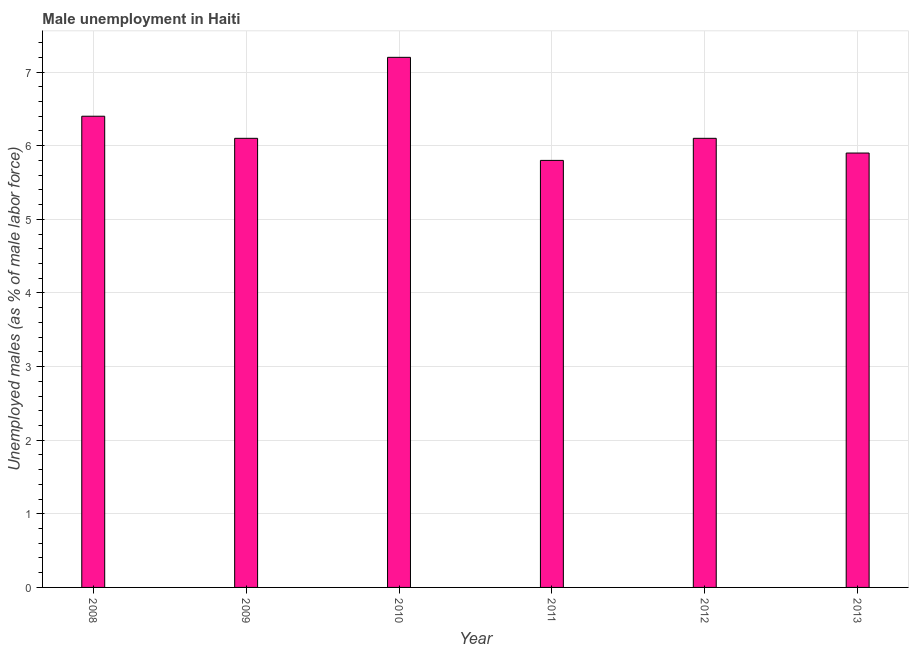What is the title of the graph?
Your answer should be very brief. Male unemployment in Haiti. What is the label or title of the Y-axis?
Your response must be concise. Unemployed males (as % of male labor force). What is the unemployed males population in 2011?
Give a very brief answer. 5.8. Across all years, what is the maximum unemployed males population?
Keep it short and to the point. 7.2. Across all years, what is the minimum unemployed males population?
Ensure brevity in your answer.  5.8. In which year was the unemployed males population minimum?
Provide a succinct answer. 2011. What is the sum of the unemployed males population?
Provide a succinct answer. 37.5. What is the average unemployed males population per year?
Make the answer very short. 6.25. What is the median unemployed males population?
Your response must be concise. 6.1. Do a majority of the years between 2009 and 2012 (inclusive) have unemployed males population greater than 0.2 %?
Your response must be concise. Yes. What is the ratio of the unemployed males population in 2009 to that in 2011?
Your response must be concise. 1.05. What is the difference between the highest and the second highest unemployed males population?
Your answer should be compact. 0.8. How many bars are there?
Give a very brief answer. 6. Are all the bars in the graph horizontal?
Provide a succinct answer. No. What is the Unemployed males (as % of male labor force) of 2008?
Keep it short and to the point. 6.4. What is the Unemployed males (as % of male labor force) in 2009?
Your response must be concise. 6.1. What is the Unemployed males (as % of male labor force) in 2010?
Your answer should be very brief. 7.2. What is the Unemployed males (as % of male labor force) in 2011?
Your response must be concise. 5.8. What is the Unemployed males (as % of male labor force) in 2012?
Provide a short and direct response. 6.1. What is the Unemployed males (as % of male labor force) in 2013?
Your response must be concise. 5.9. What is the difference between the Unemployed males (as % of male labor force) in 2008 and 2009?
Your answer should be very brief. 0.3. What is the difference between the Unemployed males (as % of male labor force) in 2008 and 2013?
Ensure brevity in your answer.  0.5. What is the difference between the Unemployed males (as % of male labor force) in 2009 and 2010?
Your answer should be very brief. -1.1. What is the difference between the Unemployed males (as % of male labor force) in 2009 and 2011?
Your answer should be very brief. 0.3. What is the difference between the Unemployed males (as % of male labor force) in 2009 and 2012?
Offer a terse response. 0. What is the difference between the Unemployed males (as % of male labor force) in 2010 and 2011?
Your response must be concise. 1.4. What is the ratio of the Unemployed males (as % of male labor force) in 2008 to that in 2009?
Provide a short and direct response. 1.05. What is the ratio of the Unemployed males (as % of male labor force) in 2008 to that in 2010?
Your response must be concise. 0.89. What is the ratio of the Unemployed males (as % of male labor force) in 2008 to that in 2011?
Your response must be concise. 1.1. What is the ratio of the Unemployed males (as % of male labor force) in 2008 to that in 2012?
Your answer should be compact. 1.05. What is the ratio of the Unemployed males (as % of male labor force) in 2008 to that in 2013?
Your response must be concise. 1.08. What is the ratio of the Unemployed males (as % of male labor force) in 2009 to that in 2010?
Provide a succinct answer. 0.85. What is the ratio of the Unemployed males (as % of male labor force) in 2009 to that in 2011?
Provide a short and direct response. 1.05. What is the ratio of the Unemployed males (as % of male labor force) in 2009 to that in 2012?
Give a very brief answer. 1. What is the ratio of the Unemployed males (as % of male labor force) in 2009 to that in 2013?
Give a very brief answer. 1.03. What is the ratio of the Unemployed males (as % of male labor force) in 2010 to that in 2011?
Keep it short and to the point. 1.24. What is the ratio of the Unemployed males (as % of male labor force) in 2010 to that in 2012?
Your answer should be very brief. 1.18. What is the ratio of the Unemployed males (as % of male labor force) in 2010 to that in 2013?
Your answer should be very brief. 1.22. What is the ratio of the Unemployed males (as % of male labor force) in 2011 to that in 2012?
Your answer should be compact. 0.95. What is the ratio of the Unemployed males (as % of male labor force) in 2011 to that in 2013?
Make the answer very short. 0.98. What is the ratio of the Unemployed males (as % of male labor force) in 2012 to that in 2013?
Make the answer very short. 1.03. 